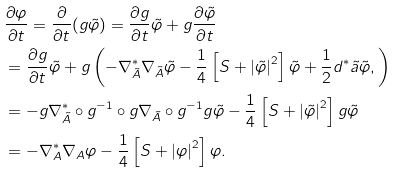<formula> <loc_0><loc_0><loc_500><loc_500>& \frac { \partial \varphi } { \partial t } = \frac { \partial } { \partial t } ( g \tilde { \varphi } ) = \frac { \partial g } { \partial t } \tilde { \varphi } + g \frac { \partial \tilde { \varphi } } { \partial t } \\ & = \frac { \partial g } { \partial t } \tilde { \varphi } + g \left ( - \nabla _ { \tilde { A } } ^ { * } \nabla _ { \tilde { A } } \tilde { \varphi } - \frac { 1 } { 4 } \left [ { S + \left | { \tilde { \varphi } } \right | ^ { 2 } } \right ] \tilde { \varphi } + \frac { 1 } { 2 } d ^ { * } \tilde { a } \tilde { \varphi } , \right ) \\ & = - g \nabla _ { \tilde { A } } ^ { * } \circ g ^ { - 1 } \circ g \nabla _ { \tilde { A } } \circ g ^ { - 1 } g \tilde { \varphi } - \frac { 1 } { 4 } \left [ S + \left | { \tilde { \varphi } } \right | ^ { 2 } \right ] g \tilde { \varphi } \\ & = - \nabla _ { A } ^ { * } \nabla _ { A } \varphi - \frac { 1 } { 4 } \left [ S + \left | { \varphi } \right | ^ { 2 } \right ] \varphi .</formula> 